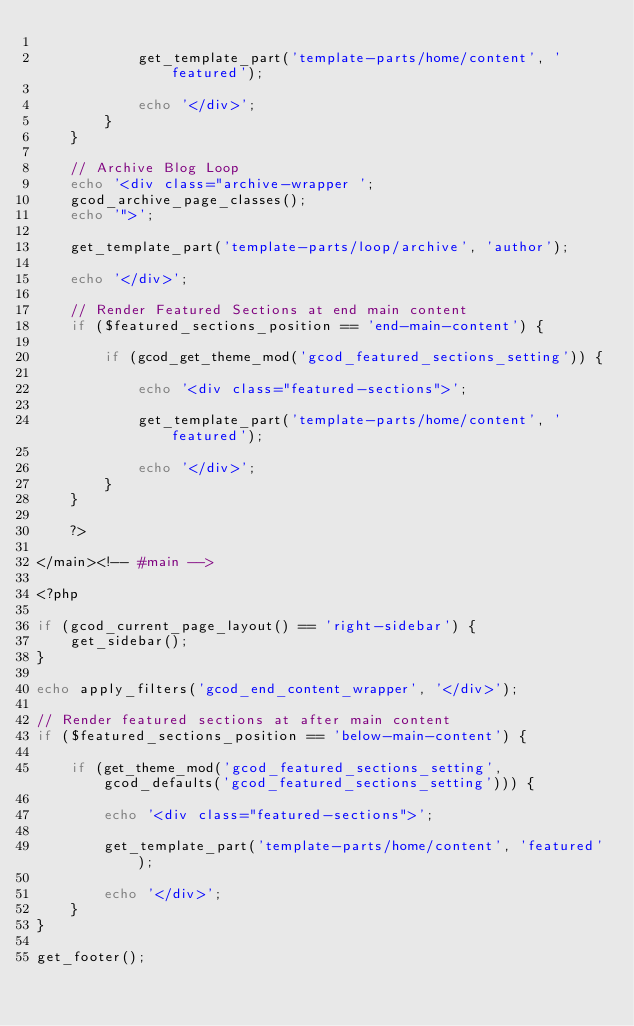<code> <loc_0><loc_0><loc_500><loc_500><_PHP_>
			get_template_part('template-parts/home/content', 'featured');

			echo '</div>';
		}
	}

	// Archive Blog Loop
	echo '<div class="archive-wrapper ';
	gcod_archive_page_classes();
	echo '">';

	get_template_part('template-parts/loop/archive', 'author');

	echo '</div>';

	// Render Featured Sections at end main content		
	if ($featured_sections_position == 'end-main-content') {

		if (gcod_get_theme_mod('gcod_featured_sections_setting')) {

			echo '<div class="featured-sections">';

			get_template_part('template-parts/home/content', 'featured');

			echo '</div>';
		}
	}

	?>

</main><!-- #main -->

<?php

if (gcod_current_page_layout() == 'right-sidebar') {
	get_sidebar();
}

echo apply_filters('gcod_end_content_wrapper', '</div>');

// Render featured sections at after main content
if ($featured_sections_position == 'below-main-content') {

	if (get_theme_mod('gcod_featured_sections_setting', gcod_defaults('gcod_featured_sections_setting'))) {

		echo '<div class="featured-sections">';

		get_template_part('template-parts/home/content', 'featured');

		echo '</div>';
	}
}

get_footer();</code> 